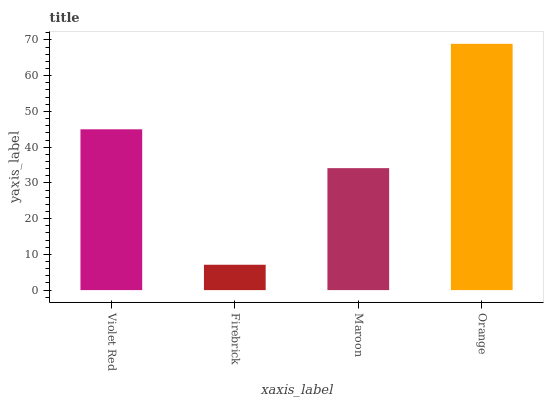Is Firebrick the minimum?
Answer yes or no. Yes. Is Orange the maximum?
Answer yes or no. Yes. Is Maroon the minimum?
Answer yes or no. No. Is Maroon the maximum?
Answer yes or no. No. Is Maroon greater than Firebrick?
Answer yes or no. Yes. Is Firebrick less than Maroon?
Answer yes or no. Yes. Is Firebrick greater than Maroon?
Answer yes or no. No. Is Maroon less than Firebrick?
Answer yes or no. No. Is Violet Red the high median?
Answer yes or no. Yes. Is Maroon the low median?
Answer yes or no. Yes. Is Firebrick the high median?
Answer yes or no. No. Is Violet Red the low median?
Answer yes or no. No. 